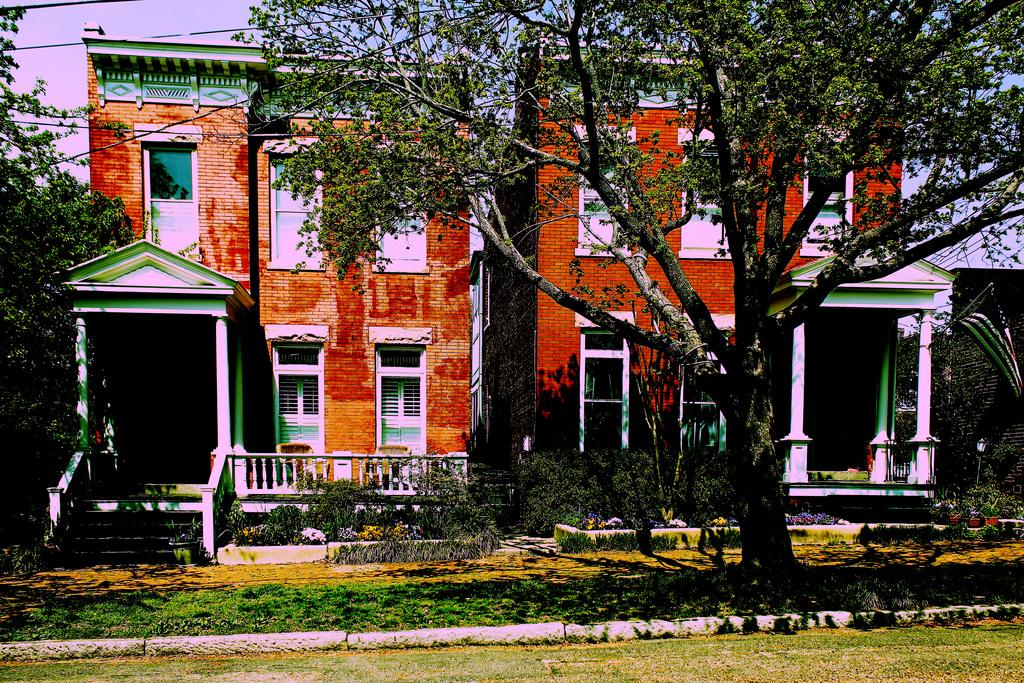What is the main structure in the image? There is a building in the image. What feature of the building is mentioned in the facts? The building has many windows. What can be seen in front of the building? There are trees in front of the building. On what surface are the trees located? The trees are on the grass. What is the income of the father in the image? There is no father or income mentioned in the image; it only features a building, windows, trees, and grass. 